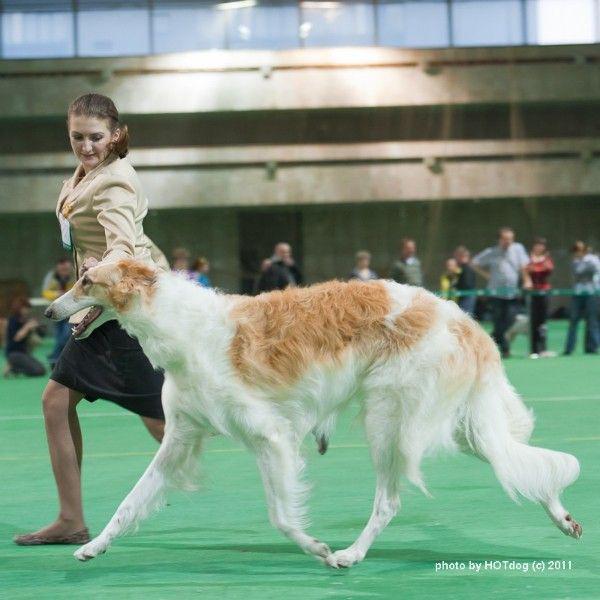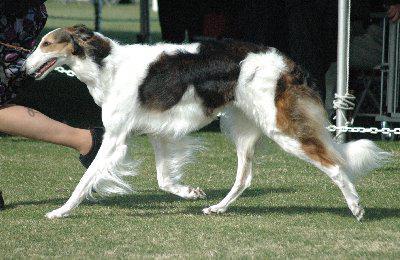The first image is the image on the left, the second image is the image on the right. Considering the images on both sides, is "All hounds shown are trotting on a green surface, and one of the dogs is trotting leftward alongside a person on green carpet." valid? Answer yes or no. Yes. The first image is the image on the left, the second image is the image on the right. Considering the images on both sides, is "One of the dogs is on artificial turf." valid? Answer yes or no. Yes. 